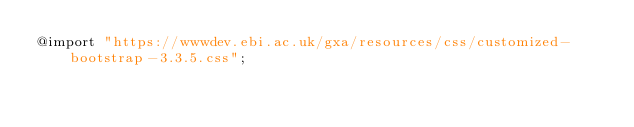<code> <loc_0><loc_0><loc_500><loc_500><_CSS_>@import "https://wwwdev.ebi.ac.uk/gxa/resources/css/customized-bootstrap-3.3.5.css";
</code> 